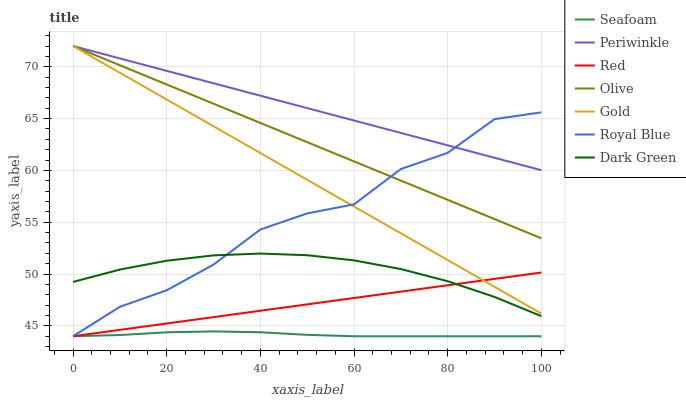Does Seafoam have the minimum area under the curve?
Answer yes or no. Yes. Does Periwinkle have the maximum area under the curve?
Answer yes or no. Yes. Does Royal Blue have the minimum area under the curve?
Answer yes or no. No. Does Royal Blue have the maximum area under the curve?
Answer yes or no. No. Is Olive the smoothest?
Answer yes or no. Yes. Is Royal Blue the roughest?
Answer yes or no. Yes. Is Seafoam the smoothest?
Answer yes or no. No. Is Seafoam the roughest?
Answer yes or no. No. Does Seafoam have the lowest value?
Answer yes or no. Yes. Does Periwinkle have the lowest value?
Answer yes or no. No. Does Olive have the highest value?
Answer yes or no. Yes. Does Royal Blue have the highest value?
Answer yes or no. No. Is Seafoam less than Periwinkle?
Answer yes or no. Yes. Is Gold greater than Dark Green?
Answer yes or no. Yes. Does Royal Blue intersect Olive?
Answer yes or no. Yes. Is Royal Blue less than Olive?
Answer yes or no. No. Is Royal Blue greater than Olive?
Answer yes or no. No. Does Seafoam intersect Periwinkle?
Answer yes or no. No. 